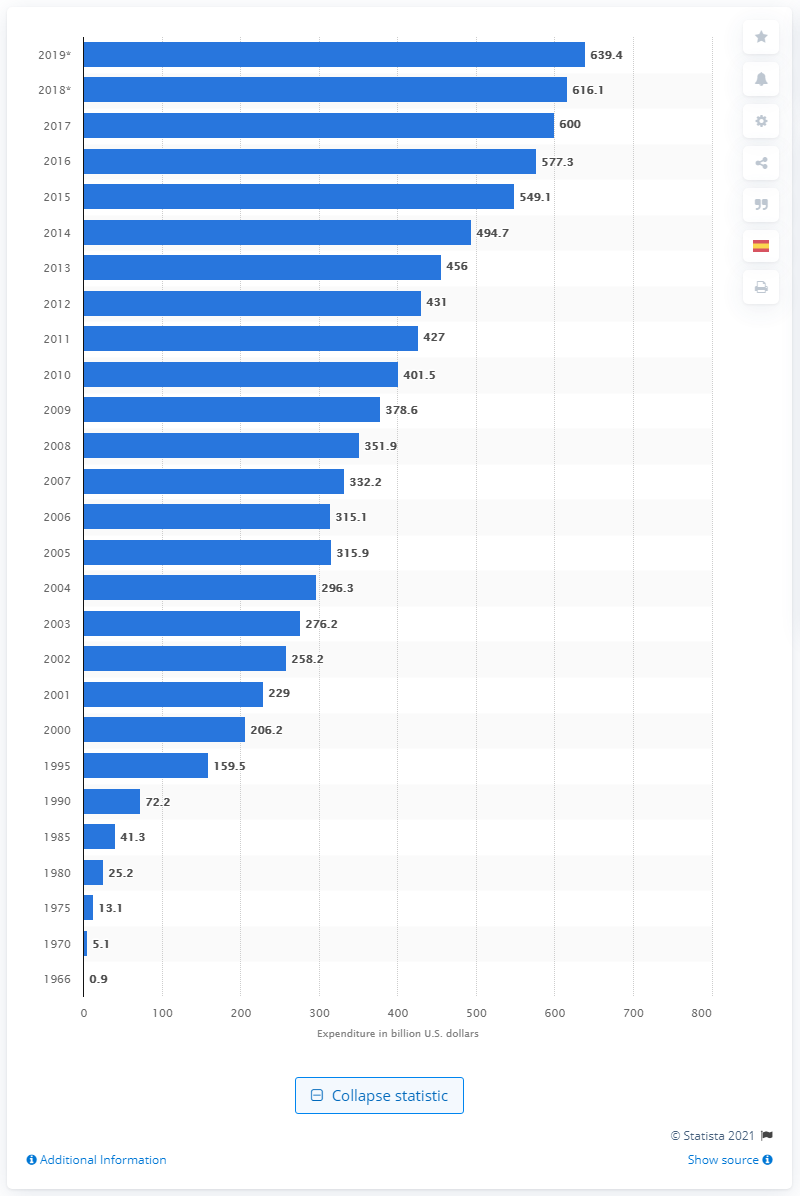Give some essential details in this illustration. In 2019, the amount of money spent on Medicaid was 639.4 billion dollars. 